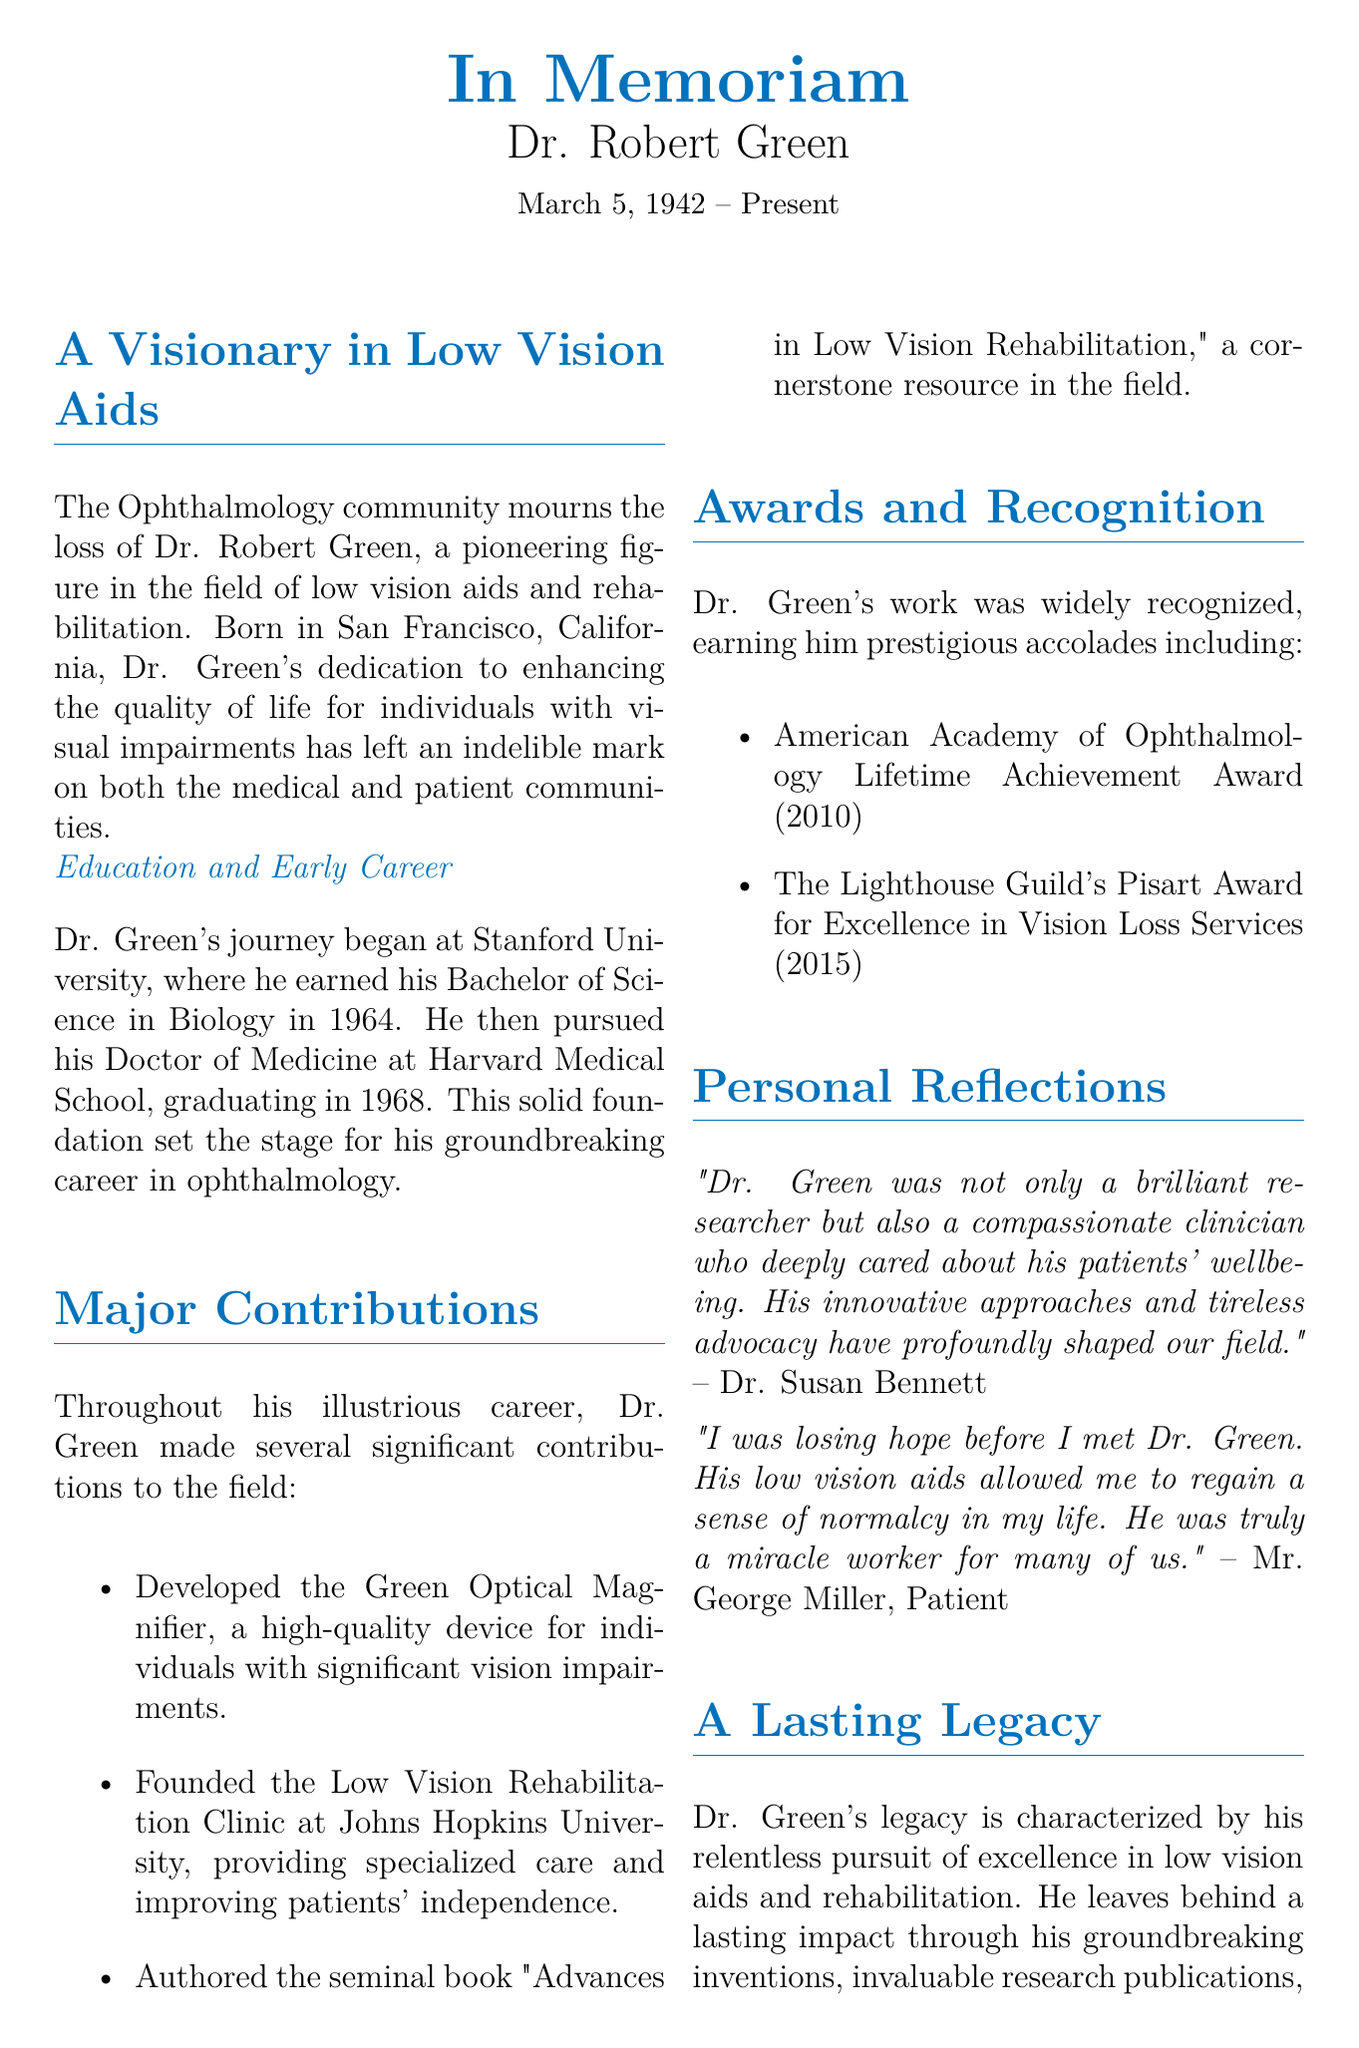What date was Dr. Robert Green born? The document states that Dr. Robert Green was born on March 5, 1942.
Answer: March 5, 1942 What degree did Dr. Green earn at Stanford University? Dr. Green earned a Bachelor of Science in Biology at Stanford University.
Answer: Bachelor of Science in Biology What is the name of the book authored by Dr. Green? The book authored by Dr. Green is titled "Advances in Low Vision Rehabilitation."
Answer: Advances in Low Vision Rehabilitation In what year did Dr. Green receive the Lifetime Achievement Award? The document mentions that Dr. Green received the American Academy of Ophthalmology Lifetime Achievement Award in 2010.
Answer: 2010 What major contribution did Dr. Green make related to the Low Vision Rehabilitation Clinic? Dr. Green founded the Low Vision Rehabilitation Clinic at Johns Hopkins University.
Answer: Founded the Low Vision Rehabilitation Clinic How does Mr. George Miller describe Dr. Green's impact on his life? Mr. George Miller describes Dr. Green as a "miracle worker for many of us."
Answer: Miracle worker What characterizes Dr. Green's legacy? Dr. Green's legacy is characterized by his relentless pursuit of excellence in low vision aids and rehabilitation.
Answer: Relentless pursuit of excellence What was Dr. Green's profession? According to the document, Dr. Green was a pioneering figure in the field of ophthalmology.
Answer: Ophthalmologist 